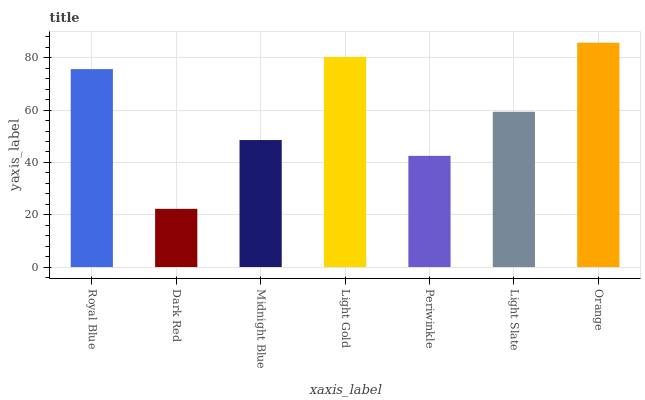Is Dark Red the minimum?
Answer yes or no. Yes. Is Orange the maximum?
Answer yes or no. Yes. Is Midnight Blue the minimum?
Answer yes or no. No. Is Midnight Blue the maximum?
Answer yes or no. No. Is Midnight Blue greater than Dark Red?
Answer yes or no. Yes. Is Dark Red less than Midnight Blue?
Answer yes or no. Yes. Is Dark Red greater than Midnight Blue?
Answer yes or no. No. Is Midnight Blue less than Dark Red?
Answer yes or no. No. Is Light Slate the high median?
Answer yes or no. Yes. Is Light Slate the low median?
Answer yes or no. Yes. Is Periwinkle the high median?
Answer yes or no. No. Is Orange the low median?
Answer yes or no. No. 